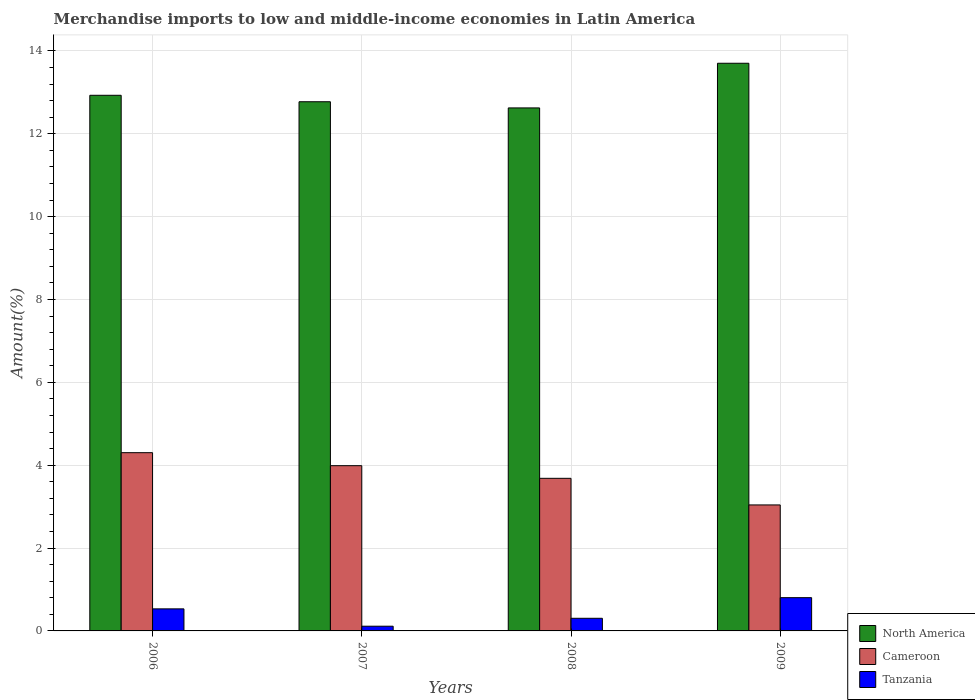How many different coloured bars are there?
Give a very brief answer. 3. How many groups of bars are there?
Make the answer very short. 4. Are the number of bars per tick equal to the number of legend labels?
Provide a succinct answer. Yes. Are the number of bars on each tick of the X-axis equal?
Offer a terse response. Yes. What is the label of the 2nd group of bars from the left?
Give a very brief answer. 2007. What is the percentage of amount earned from merchandise imports in Tanzania in 2008?
Your response must be concise. 0.31. Across all years, what is the maximum percentage of amount earned from merchandise imports in Cameroon?
Make the answer very short. 4.3. Across all years, what is the minimum percentage of amount earned from merchandise imports in North America?
Ensure brevity in your answer.  12.62. What is the total percentage of amount earned from merchandise imports in Cameroon in the graph?
Offer a very short reply. 15.02. What is the difference between the percentage of amount earned from merchandise imports in Cameroon in 2006 and that in 2008?
Your answer should be very brief. 0.62. What is the difference between the percentage of amount earned from merchandise imports in North America in 2007 and the percentage of amount earned from merchandise imports in Tanzania in 2008?
Make the answer very short. 12.47. What is the average percentage of amount earned from merchandise imports in North America per year?
Your answer should be very brief. 13.01. In the year 2006, what is the difference between the percentage of amount earned from merchandise imports in North America and percentage of amount earned from merchandise imports in Cameroon?
Give a very brief answer. 8.63. What is the ratio of the percentage of amount earned from merchandise imports in Tanzania in 2006 to that in 2009?
Keep it short and to the point. 0.66. Is the percentage of amount earned from merchandise imports in Tanzania in 2008 less than that in 2009?
Your response must be concise. Yes. What is the difference between the highest and the second highest percentage of amount earned from merchandise imports in North America?
Make the answer very short. 0.77. What is the difference between the highest and the lowest percentage of amount earned from merchandise imports in North America?
Make the answer very short. 1.08. In how many years, is the percentage of amount earned from merchandise imports in Cameroon greater than the average percentage of amount earned from merchandise imports in Cameroon taken over all years?
Give a very brief answer. 2. What does the 2nd bar from the left in 2006 represents?
Make the answer very short. Cameroon. What does the 2nd bar from the right in 2006 represents?
Provide a short and direct response. Cameroon. How many bars are there?
Provide a short and direct response. 12. How many years are there in the graph?
Offer a terse response. 4. Are the values on the major ticks of Y-axis written in scientific E-notation?
Provide a succinct answer. No. Does the graph contain any zero values?
Make the answer very short. No. Does the graph contain grids?
Your answer should be very brief. Yes. How many legend labels are there?
Provide a succinct answer. 3. How are the legend labels stacked?
Offer a very short reply. Vertical. What is the title of the graph?
Ensure brevity in your answer.  Merchandise imports to low and middle-income economies in Latin America. Does "Fragile and conflict affected situations" appear as one of the legend labels in the graph?
Keep it short and to the point. No. What is the label or title of the Y-axis?
Your response must be concise. Amount(%). What is the Amount(%) of North America in 2006?
Your response must be concise. 12.93. What is the Amount(%) of Cameroon in 2006?
Make the answer very short. 4.3. What is the Amount(%) of Tanzania in 2006?
Your answer should be very brief. 0.53. What is the Amount(%) in North America in 2007?
Give a very brief answer. 12.77. What is the Amount(%) in Cameroon in 2007?
Provide a short and direct response. 3.99. What is the Amount(%) in Tanzania in 2007?
Keep it short and to the point. 0.11. What is the Amount(%) of North America in 2008?
Your answer should be compact. 12.62. What is the Amount(%) in Cameroon in 2008?
Your answer should be very brief. 3.68. What is the Amount(%) in Tanzania in 2008?
Keep it short and to the point. 0.31. What is the Amount(%) of North America in 2009?
Make the answer very short. 13.7. What is the Amount(%) in Cameroon in 2009?
Provide a succinct answer. 3.04. What is the Amount(%) of Tanzania in 2009?
Offer a very short reply. 0.8. Across all years, what is the maximum Amount(%) of North America?
Provide a short and direct response. 13.7. Across all years, what is the maximum Amount(%) of Cameroon?
Make the answer very short. 4.3. Across all years, what is the maximum Amount(%) in Tanzania?
Ensure brevity in your answer.  0.8. Across all years, what is the minimum Amount(%) in North America?
Your answer should be very brief. 12.62. Across all years, what is the minimum Amount(%) in Cameroon?
Provide a short and direct response. 3.04. Across all years, what is the minimum Amount(%) of Tanzania?
Provide a short and direct response. 0.11. What is the total Amount(%) in North America in the graph?
Make the answer very short. 52.03. What is the total Amount(%) in Cameroon in the graph?
Give a very brief answer. 15.02. What is the total Amount(%) in Tanzania in the graph?
Your answer should be very brief. 1.75. What is the difference between the Amount(%) in North America in 2006 and that in 2007?
Make the answer very short. 0.16. What is the difference between the Amount(%) in Cameroon in 2006 and that in 2007?
Make the answer very short. 0.31. What is the difference between the Amount(%) of Tanzania in 2006 and that in 2007?
Your answer should be very brief. 0.42. What is the difference between the Amount(%) in North America in 2006 and that in 2008?
Ensure brevity in your answer.  0.3. What is the difference between the Amount(%) of Cameroon in 2006 and that in 2008?
Your answer should be very brief. 0.62. What is the difference between the Amount(%) of Tanzania in 2006 and that in 2008?
Offer a very short reply. 0.23. What is the difference between the Amount(%) of North America in 2006 and that in 2009?
Offer a terse response. -0.77. What is the difference between the Amount(%) in Cameroon in 2006 and that in 2009?
Offer a terse response. 1.26. What is the difference between the Amount(%) of Tanzania in 2006 and that in 2009?
Your response must be concise. -0.27. What is the difference between the Amount(%) of North America in 2007 and that in 2008?
Provide a succinct answer. 0.15. What is the difference between the Amount(%) of Cameroon in 2007 and that in 2008?
Your answer should be compact. 0.31. What is the difference between the Amount(%) of Tanzania in 2007 and that in 2008?
Provide a succinct answer. -0.19. What is the difference between the Amount(%) in North America in 2007 and that in 2009?
Ensure brevity in your answer.  -0.93. What is the difference between the Amount(%) in Cameroon in 2007 and that in 2009?
Offer a very short reply. 0.95. What is the difference between the Amount(%) of Tanzania in 2007 and that in 2009?
Offer a very short reply. -0.69. What is the difference between the Amount(%) of North America in 2008 and that in 2009?
Ensure brevity in your answer.  -1.08. What is the difference between the Amount(%) in Cameroon in 2008 and that in 2009?
Your answer should be very brief. 0.64. What is the difference between the Amount(%) in Tanzania in 2008 and that in 2009?
Give a very brief answer. -0.5. What is the difference between the Amount(%) of North America in 2006 and the Amount(%) of Cameroon in 2007?
Your response must be concise. 8.94. What is the difference between the Amount(%) of North America in 2006 and the Amount(%) of Tanzania in 2007?
Make the answer very short. 12.82. What is the difference between the Amount(%) of Cameroon in 2006 and the Amount(%) of Tanzania in 2007?
Provide a short and direct response. 4.19. What is the difference between the Amount(%) of North America in 2006 and the Amount(%) of Cameroon in 2008?
Ensure brevity in your answer.  9.25. What is the difference between the Amount(%) in North America in 2006 and the Amount(%) in Tanzania in 2008?
Keep it short and to the point. 12.62. What is the difference between the Amount(%) in Cameroon in 2006 and the Amount(%) in Tanzania in 2008?
Offer a terse response. 4. What is the difference between the Amount(%) in North America in 2006 and the Amount(%) in Cameroon in 2009?
Offer a very short reply. 9.89. What is the difference between the Amount(%) of North America in 2006 and the Amount(%) of Tanzania in 2009?
Your answer should be compact. 12.13. What is the difference between the Amount(%) in Cameroon in 2006 and the Amount(%) in Tanzania in 2009?
Your answer should be compact. 3.5. What is the difference between the Amount(%) in North America in 2007 and the Amount(%) in Cameroon in 2008?
Your answer should be very brief. 9.09. What is the difference between the Amount(%) of North America in 2007 and the Amount(%) of Tanzania in 2008?
Make the answer very short. 12.47. What is the difference between the Amount(%) in Cameroon in 2007 and the Amount(%) in Tanzania in 2008?
Offer a very short reply. 3.68. What is the difference between the Amount(%) of North America in 2007 and the Amount(%) of Cameroon in 2009?
Make the answer very short. 9.73. What is the difference between the Amount(%) of North America in 2007 and the Amount(%) of Tanzania in 2009?
Offer a terse response. 11.97. What is the difference between the Amount(%) in Cameroon in 2007 and the Amount(%) in Tanzania in 2009?
Offer a terse response. 3.19. What is the difference between the Amount(%) of North America in 2008 and the Amount(%) of Cameroon in 2009?
Provide a short and direct response. 9.58. What is the difference between the Amount(%) of North America in 2008 and the Amount(%) of Tanzania in 2009?
Provide a short and direct response. 11.82. What is the difference between the Amount(%) of Cameroon in 2008 and the Amount(%) of Tanzania in 2009?
Offer a very short reply. 2.88. What is the average Amount(%) of North America per year?
Your answer should be compact. 13.01. What is the average Amount(%) in Cameroon per year?
Provide a succinct answer. 3.75. What is the average Amount(%) of Tanzania per year?
Offer a terse response. 0.44. In the year 2006, what is the difference between the Amount(%) in North America and Amount(%) in Cameroon?
Give a very brief answer. 8.63. In the year 2006, what is the difference between the Amount(%) of North America and Amount(%) of Tanzania?
Provide a short and direct response. 12.4. In the year 2006, what is the difference between the Amount(%) of Cameroon and Amount(%) of Tanzania?
Ensure brevity in your answer.  3.77. In the year 2007, what is the difference between the Amount(%) in North America and Amount(%) in Cameroon?
Ensure brevity in your answer.  8.78. In the year 2007, what is the difference between the Amount(%) of North America and Amount(%) of Tanzania?
Keep it short and to the point. 12.66. In the year 2007, what is the difference between the Amount(%) in Cameroon and Amount(%) in Tanzania?
Give a very brief answer. 3.88. In the year 2008, what is the difference between the Amount(%) in North America and Amount(%) in Cameroon?
Your answer should be compact. 8.94. In the year 2008, what is the difference between the Amount(%) of North America and Amount(%) of Tanzania?
Your answer should be compact. 12.32. In the year 2008, what is the difference between the Amount(%) of Cameroon and Amount(%) of Tanzania?
Provide a succinct answer. 3.38. In the year 2009, what is the difference between the Amount(%) of North America and Amount(%) of Cameroon?
Your response must be concise. 10.66. In the year 2009, what is the difference between the Amount(%) of North America and Amount(%) of Tanzania?
Provide a short and direct response. 12.9. In the year 2009, what is the difference between the Amount(%) of Cameroon and Amount(%) of Tanzania?
Your response must be concise. 2.24. What is the ratio of the Amount(%) in North America in 2006 to that in 2007?
Your response must be concise. 1.01. What is the ratio of the Amount(%) in Cameroon in 2006 to that in 2007?
Ensure brevity in your answer.  1.08. What is the ratio of the Amount(%) of Tanzania in 2006 to that in 2007?
Provide a succinct answer. 4.69. What is the ratio of the Amount(%) of North America in 2006 to that in 2008?
Ensure brevity in your answer.  1.02. What is the ratio of the Amount(%) of Cameroon in 2006 to that in 2008?
Provide a succinct answer. 1.17. What is the ratio of the Amount(%) in Tanzania in 2006 to that in 2008?
Make the answer very short. 1.75. What is the ratio of the Amount(%) in North America in 2006 to that in 2009?
Provide a succinct answer. 0.94. What is the ratio of the Amount(%) of Cameroon in 2006 to that in 2009?
Provide a short and direct response. 1.41. What is the ratio of the Amount(%) in Tanzania in 2006 to that in 2009?
Give a very brief answer. 0.66. What is the ratio of the Amount(%) of North America in 2007 to that in 2008?
Offer a terse response. 1.01. What is the ratio of the Amount(%) in Cameroon in 2007 to that in 2008?
Provide a succinct answer. 1.08. What is the ratio of the Amount(%) of Tanzania in 2007 to that in 2008?
Offer a terse response. 0.37. What is the ratio of the Amount(%) in North America in 2007 to that in 2009?
Offer a terse response. 0.93. What is the ratio of the Amount(%) of Cameroon in 2007 to that in 2009?
Offer a terse response. 1.31. What is the ratio of the Amount(%) of Tanzania in 2007 to that in 2009?
Your answer should be very brief. 0.14. What is the ratio of the Amount(%) of North America in 2008 to that in 2009?
Your answer should be compact. 0.92. What is the ratio of the Amount(%) of Cameroon in 2008 to that in 2009?
Make the answer very short. 1.21. What is the ratio of the Amount(%) in Tanzania in 2008 to that in 2009?
Your answer should be compact. 0.38. What is the difference between the highest and the second highest Amount(%) of North America?
Your answer should be compact. 0.77. What is the difference between the highest and the second highest Amount(%) in Cameroon?
Your response must be concise. 0.31. What is the difference between the highest and the second highest Amount(%) in Tanzania?
Your answer should be very brief. 0.27. What is the difference between the highest and the lowest Amount(%) of North America?
Keep it short and to the point. 1.08. What is the difference between the highest and the lowest Amount(%) in Cameroon?
Keep it short and to the point. 1.26. What is the difference between the highest and the lowest Amount(%) of Tanzania?
Make the answer very short. 0.69. 